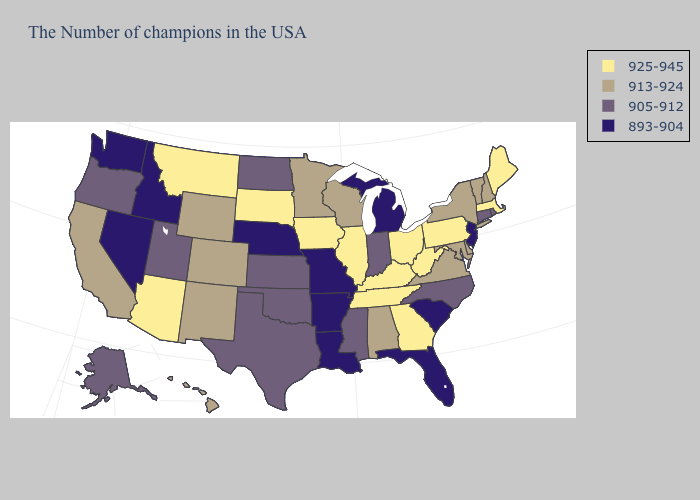What is the highest value in the West ?
Keep it brief. 925-945. Does the map have missing data?
Be succinct. No. What is the value of Iowa?
Short answer required. 925-945. Among the states that border Iowa , does Nebraska have the lowest value?
Quick response, please. Yes. Among the states that border North Carolina , which have the lowest value?
Write a very short answer. South Carolina. What is the value of North Carolina?
Be succinct. 905-912. Does Georgia have the highest value in the USA?
Write a very short answer. Yes. What is the value of Nevada?
Be succinct. 893-904. Name the states that have a value in the range 925-945?
Answer briefly. Maine, Massachusetts, Pennsylvania, West Virginia, Ohio, Georgia, Kentucky, Tennessee, Illinois, Iowa, South Dakota, Montana, Arizona. Name the states that have a value in the range 905-912?
Keep it brief. Rhode Island, Connecticut, North Carolina, Indiana, Mississippi, Kansas, Oklahoma, Texas, North Dakota, Utah, Oregon, Alaska. Which states have the lowest value in the USA?
Short answer required. New Jersey, South Carolina, Florida, Michigan, Louisiana, Missouri, Arkansas, Nebraska, Idaho, Nevada, Washington. What is the lowest value in the South?
Be succinct. 893-904. Name the states that have a value in the range 893-904?
Keep it brief. New Jersey, South Carolina, Florida, Michigan, Louisiana, Missouri, Arkansas, Nebraska, Idaho, Nevada, Washington. Does the first symbol in the legend represent the smallest category?
Write a very short answer. No. Name the states that have a value in the range 925-945?
Be succinct. Maine, Massachusetts, Pennsylvania, West Virginia, Ohio, Georgia, Kentucky, Tennessee, Illinois, Iowa, South Dakota, Montana, Arizona. 